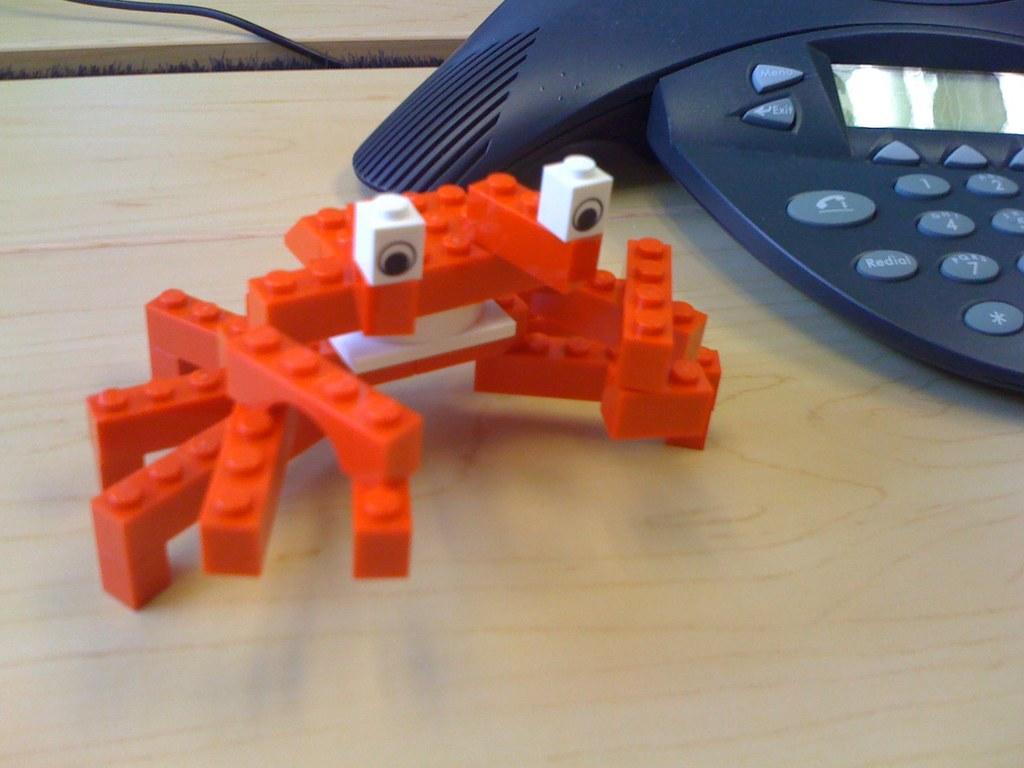What word is written on the conference phone, left of the "7" key?
Offer a terse response. Redial. Is there a 2 visible on the phone?
Give a very brief answer. Yes. 